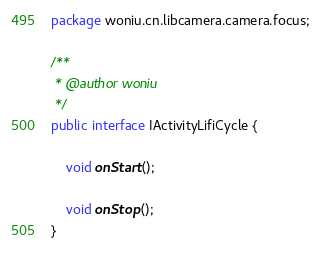Convert code to text. <code><loc_0><loc_0><loc_500><loc_500><_Java_>package woniu.cn.libcamera.camera.focus;

/**
 * @author woniu
 */
public interface IActivityLifiCycle {

    void onStart();

    void onStop();
}
</code> 